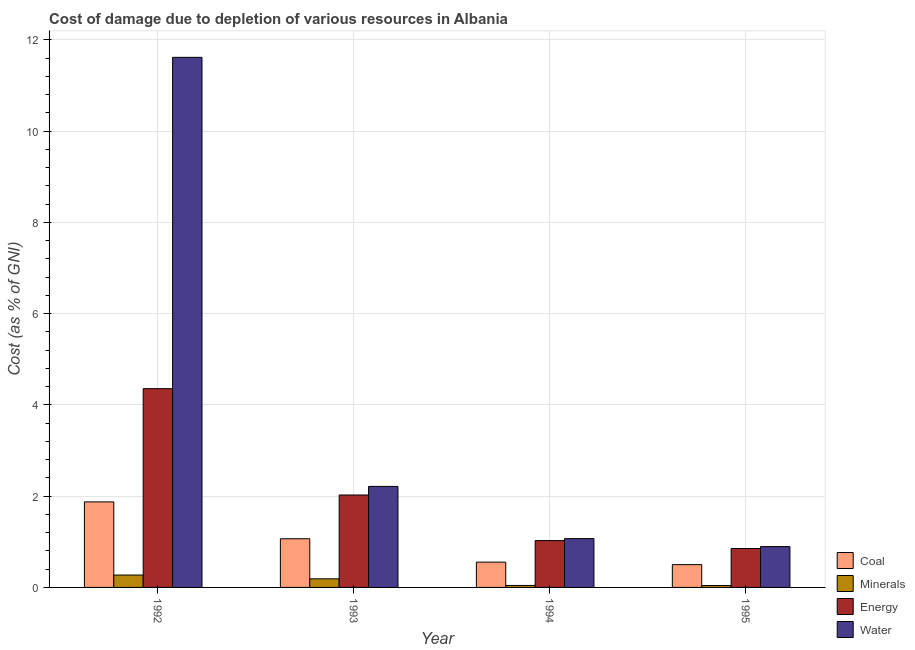How many different coloured bars are there?
Provide a succinct answer. 4. How many groups of bars are there?
Make the answer very short. 4. Are the number of bars on each tick of the X-axis equal?
Provide a short and direct response. Yes. How many bars are there on the 3rd tick from the right?
Make the answer very short. 4. What is the cost of damage due to depletion of coal in 1994?
Give a very brief answer. 0.55. Across all years, what is the maximum cost of damage due to depletion of minerals?
Your answer should be very brief. 0.27. Across all years, what is the minimum cost of damage due to depletion of water?
Your response must be concise. 0.9. In which year was the cost of damage due to depletion of coal maximum?
Ensure brevity in your answer.  1992. What is the total cost of damage due to depletion of energy in the graph?
Ensure brevity in your answer.  8.26. What is the difference between the cost of damage due to depletion of energy in 1993 and that in 1994?
Provide a succinct answer. 1. What is the difference between the cost of damage due to depletion of energy in 1992 and the cost of damage due to depletion of water in 1995?
Offer a terse response. 3.5. What is the average cost of damage due to depletion of minerals per year?
Provide a succinct answer. 0.14. In how many years, is the cost of damage due to depletion of minerals greater than 4.4 %?
Your answer should be compact. 0. What is the ratio of the cost of damage due to depletion of energy in 1992 to that in 1994?
Your answer should be very brief. 4.25. Is the cost of damage due to depletion of coal in 1993 less than that in 1994?
Make the answer very short. No. Is the difference between the cost of damage due to depletion of minerals in 1994 and 1995 greater than the difference between the cost of damage due to depletion of energy in 1994 and 1995?
Your answer should be compact. No. What is the difference between the highest and the second highest cost of damage due to depletion of energy?
Your answer should be compact. 2.33. What is the difference between the highest and the lowest cost of damage due to depletion of minerals?
Your answer should be compact. 0.23. Is the sum of the cost of damage due to depletion of minerals in 1992 and 1995 greater than the maximum cost of damage due to depletion of coal across all years?
Your answer should be very brief. Yes. Is it the case that in every year, the sum of the cost of damage due to depletion of coal and cost of damage due to depletion of minerals is greater than the sum of cost of damage due to depletion of water and cost of damage due to depletion of energy?
Your answer should be very brief. Yes. What does the 2nd bar from the left in 1993 represents?
Offer a very short reply. Minerals. What does the 4th bar from the right in 1994 represents?
Keep it short and to the point. Coal. How many years are there in the graph?
Keep it short and to the point. 4. Does the graph contain any zero values?
Your response must be concise. No. Where does the legend appear in the graph?
Offer a terse response. Bottom right. How many legend labels are there?
Your answer should be compact. 4. How are the legend labels stacked?
Your answer should be very brief. Vertical. What is the title of the graph?
Give a very brief answer. Cost of damage due to depletion of various resources in Albania . What is the label or title of the Y-axis?
Provide a short and direct response. Cost (as % of GNI). What is the Cost (as % of GNI) of Coal in 1992?
Ensure brevity in your answer.  1.87. What is the Cost (as % of GNI) in Minerals in 1992?
Make the answer very short. 0.27. What is the Cost (as % of GNI) of Energy in 1992?
Ensure brevity in your answer.  4.36. What is the Cost (as % of GNI) in Water in 1992?
Offer a very short reply. 11.62. What is the Cost (as % of GNI) in Coal in 1993?
Your answer should be very brief. 1.07. What is the Cost (as % of GNI) in Minerals in 1993?
Offer a terse response. 0.19. What is the Cost (as % of GNI) in Energy in 1993?
Provide a short and direct response. 2.03. What is the Cost (as % of GNI) in Water in 1993?
Provide a short and direct response. 2.21. What is the Cost (as % of GNI) of Coal in 1994?
Make the answer very short. 0.55. What is the Cost (as % of GNI) of Minerals in 1994?
Offer a terse response. 0.04. What is the Cost (as % of GNI) in Energy in 1994?
Give a very brief answer. 1.03. What is the Cost (as % of GNI) of Water in 1994?
Your response must be concise. 1.07. What is the Cost (as % of GNI) of Coal in 1995?
Offer a very short reply. 0.5. What is the Cost (as % of GNI) in Minerals in 1995?
Provide a succinct answer. 0.04. What is the Cost (as % of GNI) of Energy in 1995?
Ensure brevity in your answer.  0.85. What is the Cost (as % of GNI) in Water in 1995?
Your answer should be very brief. 0.9. Across all years, what is the maximum Cost (as % of GNI) in Coal?
Offer a terse response. 1.87. Across all years, what is the maximum Cost (as % of GNI) of Minerals?
Your response must be concise. 0.27. Across all years, what is the maximum Cost (as % of GNI) of Energy?
Your answer should be very brief. 4.36. Across all years, what is the maximum Cost (as % of GNI) in Water?
Make the answer very short. 11.62. Across all years, what is the minimum Cost (as % of GNI) in Coal?
Your answer should be very brief. 0.5. Across all years, what is the minimum Cost (as % of GNI) of Minerals?
Ensure brevity in your answer.  0.04. Across all years, what is the minimum Cost (as % of GNI) in Energy?
Your response must be concise. 0.85. Across all years, what is the minimum Cost (as % of GNI) in Water?
Your answer should be very brief. 0.9. What is the total Cost (as % of GNI) in Coal in the graph?
Give a very brief answer. 4. What is the total Cost (as % of GNI) of Minerals in the graph?
Offer a very short reply. 0.55. What is the total Cost (as % of GNI) in Energy in the graph?
Provide a succinct answer. 8.26. What is the total Cost (as % of GNI) in Water in the graph?
Keep it short and to the point. 15.8. What is the difference between the Cost (as % of GNI) of Coal in 1992 and that in 1993?
Offer a very short reply. 0.81. What is the difference between the Cost (as % of GNI) of Minerals in 1992 and that in 1993?
Make the answer very short. 0.08. What is the difference between the Cost (as % of GNI) of Energy in 1992 and that in 1993?
Your response must be concise. 2.33. What is the difference between the Cost (as % of GNI) in Water in 1992 and that in 1993?
Provide a short and direct response. 9.41. What is the difference between the Cost (as % of GNI) in Coal in 1992 and that in 1994?
Your response must be concise. 1.32. What is the difference between the Cost (as % of GNI) of Minerals in 1992 and that in 1994?
Offer a terse response. 0.23. What is the difference between the Cost (as % of GNI) in Energy in 1992 and that in 1994?
Make the answer very short. 3.33. What is the difference between the Cost (as % of GNI) of Water in 1992 and that in 1994?
Keep it short and to the point. 10.55. What is the difference between the Cost (as % of GNI) of Coal in 1992 and that in 1995?
Your answer should be compact. 1.38. What is the difference between the Cost (as % of GNI) in Minerals in 1992 and that in 1995?
Offer a terse response. 0.23. What is the difference between the Cost (as % of GNI) of Energy in 1992 and that in 1995?
Make the answer very short. 3.5. What is the difference between the Cost (as % of GNI) of Water in 1992 and that in 1995?
Provide a short and direct response. 10.72. What is the difference between the Cost (as % of GNI) in Coal in 1993 and that in 1994?
Offer a very short reply. 0.51. What is the difference between the Cost (as % of GNI) in Minerals in 1993 and that in 1994?
Ensure brevity in your answer.  0.14. What is the difference between the Cost (as % of GNI) of Energy in 1993 and that in 1994?
Your answer should be very brief. 1. What is the difference between the Cost (as % of GNI) of Water in 1993 and that in 1994?
Give a very brief answer. 1.14. What is the difference between the Cost (as % of GNI) of Coal in 1993 and that in 1995?
Offer a very short reply. 0.57. What is the difference between the Cost (as % of GNI) of Minerals in 1993 and that in 1995?
Offer a very short reply. 0.15. What is the difference between the Cost (as % of GNI) in Energy in 1993 and that in 1995?
Give a very brief answer. 1.17. What is the difference between the Cost (as % of GNI) in Water in 1993 and that in 1995?
Keep it short and to the point. 1.32. What is the difference between the Cost (as % of GNI) of Coal in 1994 and that in 1995?
Offer a very short reply. 0.05. What is the difference between the Cost (as % of GNI) of Minerals in 1994 and that in 1995?
Your answer should be very brief. 0. What is the difference between the Cost (as % of GNI) of Energy in 1994 and that in 1995?
Provide a succinct answer. 0.17. What is the difference between the Cost (as % of GNI) in Water in 1994 and that in 1995?
Offer a very short reply. 0.17. What is the difference between the Cost (as % of GNI) of Coal in 1992 and the Cost (as % of GNI) of Minerals in 1993?
Make the answer very short. 1.69. What is the difference between the Cost (as % of GNI) of Coal in 1992 and the Cost (as % of GNI) of Energy in 1993?
Provide a short and direct response. -0.15. What is the difference between the Cost (as % of GNI) of Coal in 1992 and the Cost (as % of GNI) of Water in 1993?
Keep it short and to the point. -0.34. What is the difference between the Cost (as % of GNI) of Minerals in 1992 and the Cost (as % of GNI) of Energy in 1993?
Provide a succinct answer. -1.75. What is the difference between the Cost (as % of GNI) in Minerals in 1992 and the Cost (as % of GNI) in Water in 1993?
Keep it short and to the point. -1.94. What is the difference between the Cost (as % of GNI) in Energy in 1992 and the Cost (as % of GNI) in Water in 1993?
Provide a short and direct response. 2.14. What is the difference between the Cost (as % of GNI) in Coal in 1992 and the Cost (as % of GNI) in Minerals in 1994?
Ensure brevity in your answer.  1.83. What is the difference between the Cost (as % of GNI) in Coal in 1992 and the Cost (as % of GNI) in Energy in 1994?
Your response must be concise. 0.85. What is the difference between the Cost (as % of GNI) in Coal in 1992 and the Cost (as % of GNI) in Water in 1994?
Offer a very short reply. 0.81. What is the difference between the Cost (as % of GNI) of Minerals in 1992 and the Cost (as % of GNI) of Energy in 1994?
Ensure brevity in your answer.  -0.75. What is the difference between the Cost (as % of GNI) of Minerals in 1992 and the Cost (as % of GNI) of Water in 1994?
Provide a short and direct response. -0.8. What is the difference between the Cost (as % of GNI) of Energy in 1992 and the Cost (as % of GNI) of Water in 1994?
Your response must be concise. 3.29. What is the difference between the Cost (as % of GNI) in Coal in 1992 and the Cost (as % of GNI) in Minerals in 1995?
Offer a very short reply. 1.83. What is the difference between the Cost (as % of GNI) of Coal in 1992 and the Cost (as % of GNI) of Energy in 1995?
Keep it short and to the point. 1.02. What is the difference between the Cost (as % of GNI) of Coal in 1992 and the Cost (as % of GNI) of Water in 1995?
Your answer should be very brief. 0.98. What is the difference between the Cost (as % of GNI) in Minerals in 1992 and the Cost (as % of GNI) in Energy in 1995?
Offer a very short reply. -0.58. What is the difference between the Cost (as % of GNI) of Minerals in 1992 and the Cost (as % of GNI) of Water in 1995?
Your answer should be compact. -0.62. What is the difference between the Cost (as % of GNI) in Energy in 1992 and the Cost (as % of GNI) in Water in 1995?
Your answer should be compact. 3.46. What is the difference between the Cost (as % of GNI) of Coal in 1993 and the Cost (as % of GNI) of Minerals in 1994?
Make the answer very short. 1.02. What is the difference between the Cost (as % of GNI) of Coal in 1993 and the Cost (as % of GNI) of Energy in 1994?
Provide a short and direct response. 0.04. What is the difference between the Cost (as % of GNI) in Coal in 1993 and the Cost (as % of GNI) in Water in 1994?
Your answer should be compact. -0. What is the difference between the Cost (as % of GNI) of Minerals in 1993 and the Cost (as % of GNI) of Energy in 1994?
Make the answer very short. -0.84. What is the difference between the Cost (as % of GNI) of Minerals in 1993 and the Cost (as % of GNI) of Water in 1994?
Offer a terse response. -0.88. What is the difference between the Cost (as % of GNI) of Energy in 1993 and the Cost (as % of GNI) of Water in 1994?
Give a very brief answer. 0.96. What is the difference between the Cost (as % of GNI) in Coal in 1993 and the Cost (as % of GNI) in Minerals in 1995?
Your answer should be compact. 1.02. What is the difference between the Cost (as % of GNI) of Coal in 1993 and the Cost (as % of GNI) of Energy in 1995?
Provide a short and direct response. 0.21. What is the difference between the Cost (as % of GNI) in Coal in 1993 and the Cost (as % of GNI) in Water in 1995?
Offer a very short reply. 0.17. What is the difference between the Cost (as % of GNI) of Minerals in 1993 and the Cost (as % of GNI) of Energy in 1995?
Offer a terse response. -0.66. What is the difference between the Cost (as % of GNI) in Minerals in 1993 and the Cost (as % of GNI) in Water in 1995?
Offer a very short reply. -0.71. What is the difference between the Cost (as % of GNI) of Energy in 1993 and the Cost (as % of GNI) of Water in 1995?
Offer a terse response. 1.13. What is the difference between the Cost (as % of GNI) of Coal in 1994 and the Cost (as % of GNI) of Minerals in 1995?
Offer a terse response. 0.51. What is the difference between the Cost (as % of GNI) in Coal in 1994 and the Cost (as % of GNI) in Energy in 1995?
Offer a terse response. -0.3. What is the difference between the Cost (as % of GNI) of Coal in 1994 and the Cost (as % of GNI) of Water in 1995?
Provide a short and direct response. -0.34. What is the difference between the Cost (as % of GNI) in Minerals in 1994 and the Cost (as % of GNI) in Energy in 1995?
Your response must be concise. -0.81. What is the difference between the Cost (as % of GNI) in Minerals in 1994 and the Cost (as % of GNI) in Water in 1995?
Make the answer very short. -0.85. What is the difference between the Cost (as % of GNI) in Energy in 1994 and the Cost (as % of GNI) in Water in 1995?
Give a very brief answer. 0.13. What is the average Cost (as % of GNI) in Minerals per year?
Give a very brief answer. 0.14. What is the average Cost (as % of GNI) in Energy per year?
Your response must be concise. 2.07. What is the average Cost (as % of GNI) in Water per year?
Your answer should be compact. 3.95. In the year 1992, what is the difference between the Cost (as % of GNI) of Coal and Cost (as % of GNI) of Minerals?
Provide a short and direct response. 1.6. In the year 1992, what is the difference between the Cost (as % of GNI) of Coal and Cost (as % of GNI) of Energy?
Give a very brief answer. -2.48. In the year 1992, what is the difference between the Cost (as % of GNI) of Coal and Cost (as % of GNI) of Water?
Your response must be concise. -9.74. In the year 1992, what is the difference between the Cost (as % of GNI) in Minerals and Cost (as % of GNI) in Energy?
Ensure brevity in your answer.  -4.09. In the year 1992, what is the difference between the Cost (as % of GNI) of Minerals and Cost (as % of GNI) of Water?
Provide a short and direct response. -11.35. In the year 1992, what is the difference between the Cost (as % of GNI) in Energy and Cost (as % of GNI) in Water?
Offer a terse response. -7.26. In the year 1993, what is the difference between the Cost (as % of GNI) in Coal and Cost (as % of GNI) in Minerals?
Offer a very short reply. 0.88. In the year 1993, what is the difference between the Cost (as % of GNI) of Coal and Cost (as % of GNI) of Energy?
Your answer should be compact. -0.96. In the year 1993, what is the difference between the Cost (as % of GNI) of Coal and Cost (as % of GNI) of Water?
Offer a very short reply. -1.15. In the year 1993, what is the difference between the Cost (as % of GNI) of Minerals and Cost (as % of GNI) of Energy?
Give a very brief answer. -1.84. In the year 1993, what is the difference between the Cost (as % of GNI) of Minerals and Cost (as % of GNI) of Water?
Keep it short and to the point. -2.03. In the year 1993, what is the difference between the Cost (as % of GNI) of Energy and Cost (as % of GNI) of Water?
Keep it short and to the point. -0.19. In the year 1994, what is the difference between the Cost (as % of GNI) in Coal and Cost (as % of GNI) in Minerals?
Keep it short and to the point. 0.51. In the year 1994, what is the difference between the Cost (as % of GNI) in Coal and Cost (as % of GNI) in Energy?
Your answer should be compact. -0.47. In the year 1994, what is the difference between the Cost (as % of GNI) of Coal and Cost (as % of GNI) of Water?
Your response must be concise. -0.52. In the year 1994, what is the difference between the Cost (as % of GNI) of Minerals and Cost (as % of GNI) of Energy?
Your response must be concise. -0.98. In the year 1994, what is the difference between the Cost (as % of GNI) in Minerals and Cost (as % of GNI) in Water?
Offer a terse response. -1.03. In the year 1994, what is the difference between the Cost (as % of GNI) of Energy and Cost (as % of GNI) of Water?
Ensure brevity in your answer.  -0.04. In the year 1995, what is the difference between the Cost (as % of GNI) of Coal and Cost (as % of GNI) of Minerals?
Ensure brevity in your answer.  0.46. In the year 1995, what is the difference between the Cost (as % of GNI) of Coal and Cost (as % of GNI) of Energy?
Offer a terse response. -0.35. In the year 1995, what is the difference between the Cost (as % of GNI) of Coal and Cost (as % of GNI) of Water?
Make the answer very short. -0.4. In the year 1995, what is the difference between the Cost (as % of GNI) in Minerals and Cost (as % of GNI) in Energy?
Provide a short and direct response. -0.81. In the year 1995, what is the difference between the Cost (as % of GNI) of Minerals and Cost (as % of GNI) of Water?
Offer a terse response. -0.85. In the year 1995, what is the difference between the Cost (as % of GNI) of Energy and Cost (as % of GNI) of Water?
Offer a terse response. -0.04. What is the ratio of the Cost (as % of GNI) of Coal in 1992 to that in 1993?
Offer a terse response. 1.76. What is the ratio of the Cost (as % of GNI) in Minerals in 1992 to that in 1993?
Give a very brief answer. 1.44. What is the ratio of the Cost (as % of GNI) of Energy in 1992 to that in 1993?
Your answer should be very brief. 2.15. What is the ratio of the Cost (as % of GNI) of Water in 1992 to that in 1993?
Your answer should be very brief. 5.25. What is the ratio of the Cost (as % of GNI) in Coal in 1992 to that in 1994?
Give a very brief answer. 3.38. What is the ratio of the Cost (as % of GNI) of Minerals in 1992 to that in 1994?
Provide a succinct answer. 6.25. What is the ratio of the Cost (as % of GNI) of Energy in 1992 to that in 1994?
Make the answer very short. 4.25. What is the ratio of the Cost (as % of GNI) in Water in 1992 to that in 1994?
Provide a short and direct response. 10.86. What is the ratio of the Cost (as % of GNI) of Coal in 1992 to that in 1995?
Offer a terse response. 3.75. What is the ratio of the Cost (as % of GNI) in Minerals in 1992 to that in 1995?
Offer a terse response. 6.46. What is the ratio of the Cost (as % of GNI) of Energy in 1992 to that in 1995?
Provide a succinct answer. 5.11. What is the ratio of the Cost (as % of GNI) of Water in 1992 to that in 1995?
Make the answer very short. 12.98. What is the ratio of the Cost (as % of GNI) of Coal in 1993 to that in 1994?
Make the answer very short. 1.92. What is the ratio of the Cost (as % of GNI) of Minerals in 1993 to that in 1994?
Provide a short and direct response. 4.34. What is the ratio of the Cost (as % of GNI) in Energy in 1993 to that in 1994?
Keep it short and to the point. 1.97. What is the ratio of the Cost (as % of GNI) of Water in 1993 to that in 1994?
Make the answer very short. 2.07. What is the ratio of the Cost (as % of GNI) of Coal in 1993 to that in 1995?
Give a very brief answer. 2.14. What is the ratio of the Cost (as % of GNI) of Minerals in 1993 to that in 1995?
Your answer should be very brief. 4.49. What is the ratio of the Cost (as % of GNI) in Energy in 1993 to that in 1995?
Offer a terse response. 2.37. What is the ratio of the Cost (as % of GNI) in Water in 1993 to that in 1995?
Your answer should be very brief. 2.47. What is the ratio of the Cost (as % of GNI) of Coal in 1994 to that in 1995?
Give a very brief answer. 1.11. What is the ratio of the Cost (as % of GNI) in Minerals in 1994 to that in 1995?
Keep it short and to the point. 1.03. What is the ratio of the Cost (as % of GNI) in Energy in 1994 to that in 1995?
Make the answer very short. 1.2. What is the ratio of the Cost (as % of GNI) in Water in 1994 to that in 1995?
Offer a very short reply. 1.2. What is the difference between the highest and the second highest Cost (as % of GNI) in Coal?
Your response must be concise. 0.81. What is the difference between the highest and the second highest Cost (as % of GNI) of Minerals?
Make the answer very short. 0.08. What is the difference between the highest and the second highest Cost (as % of GNI) in Energy?
Your answer should be very brief. 2.33. What is the difference between the highest and the second highest Cost (as % of GNI) in Water?
Offer a terse response. 9.41. What is the difference between the highest and the lowest Cost (as % of GNI) in Coal?
Give a very brief answer. 1.38. What is the difference between the highest and the lowest Cost (as % of GNI) in Minerals?
Your answer should be compact. 0.23. What is the difference between the highest and the lowest Cost (as % of GNI) of Energy?
Offer a terse response. 3.5. What is the difference between the highest and the lowest Cost (as % of GNI) in Water?
Keep it short and to the point. 10.72. 